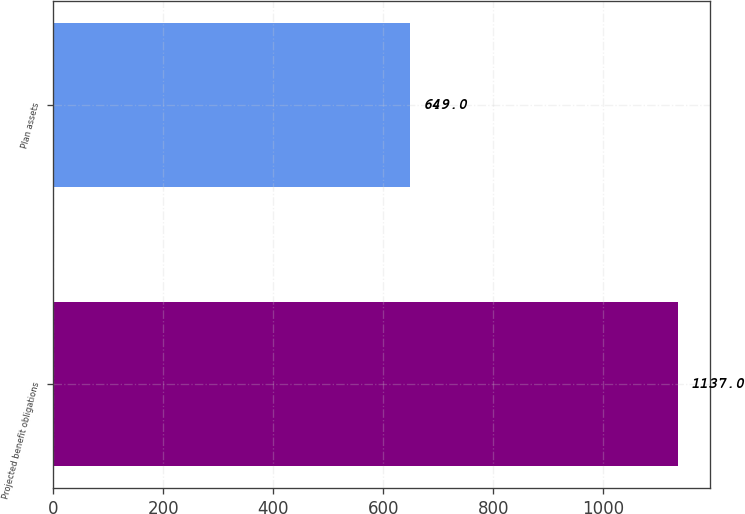Convert chart to OTSL. <chart><loc_0><loc_0><loc_500><loc_500><bar_chart><fcel>Projected benefit obligations<fcel>Plan assets<nl><fcel>1137<fcel>649<nl></chart> 